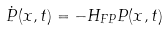<formula> <loc_0><loc_0><loc_500><loc_500>\dot { P } ( { x } , t ) = - H _ { F P } P ( { x } , t )</formula> 